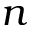Convert formula to latex. <formula><loc_0><loc_0><loc_500><loc_500>n</formula> 